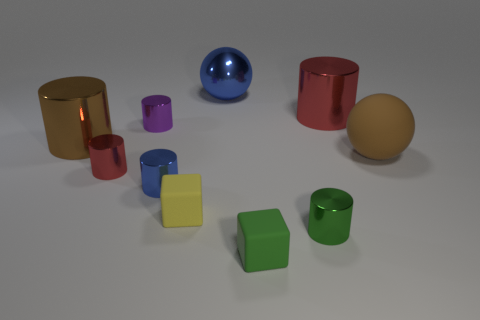Subtract all green cylinders. How many cylinders are left? 5 Subtract all red shiny cylinders. How many cylinders are left? 4 Subtract all cyan cylinders. Subtract all cyan spheres. How many cylinders are left? 6 Subtract all spheres. How many objects are left? 8 Subtract all large rubber objects. Subtract all big metallic cylinders. How many objects are left? 7 Add 7 small blue objects. How many small blue objects are left? 8 Add 1 tiny brown metal spheres. How many tiny brown metal spheres exist? 1 Subtract 1 blue cylinders. How many objects are left? 9 